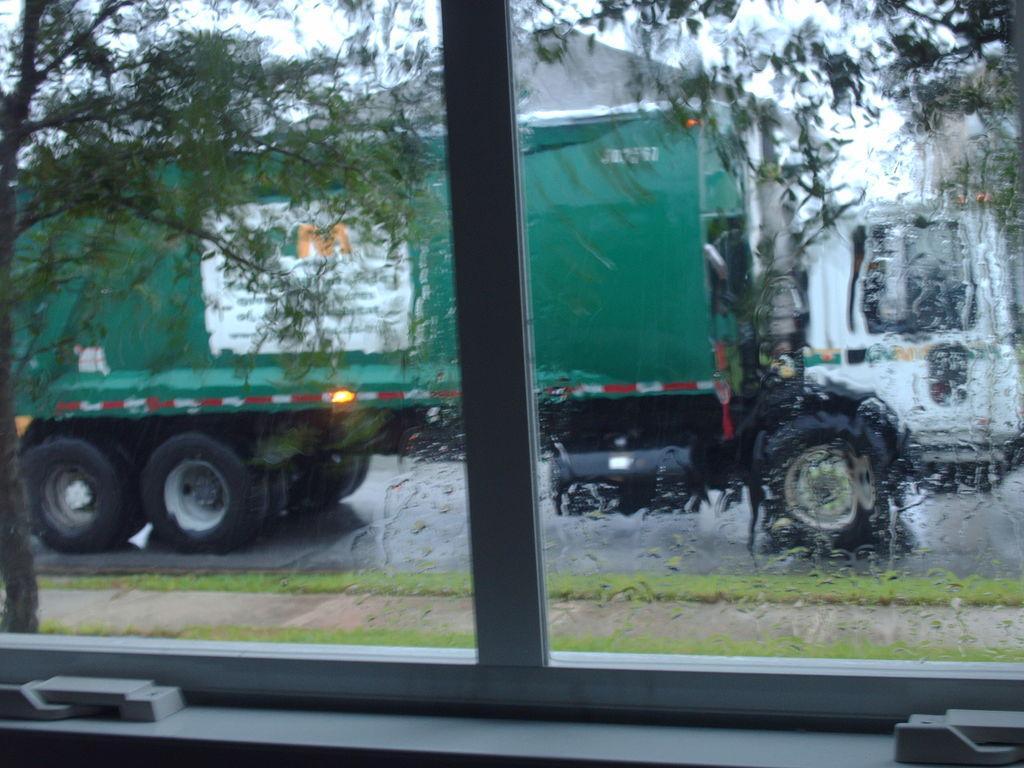Please provide a concise description of this image. This is an inside view. Here I can see a glass through which we can see the outside view. In outside there are some trees, a building and a vehicle on the road. 